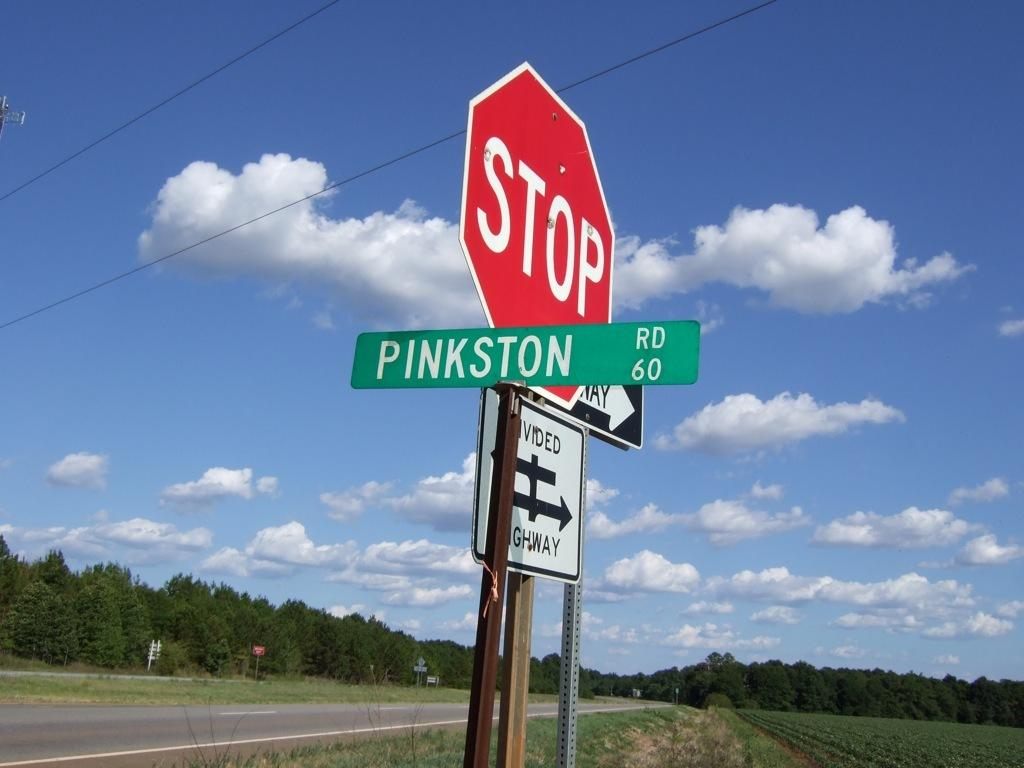<image>
Offer a succinct explanation of the picture presented. A red stop sign is next to a green street sign that says Pinkston Rd 60. 